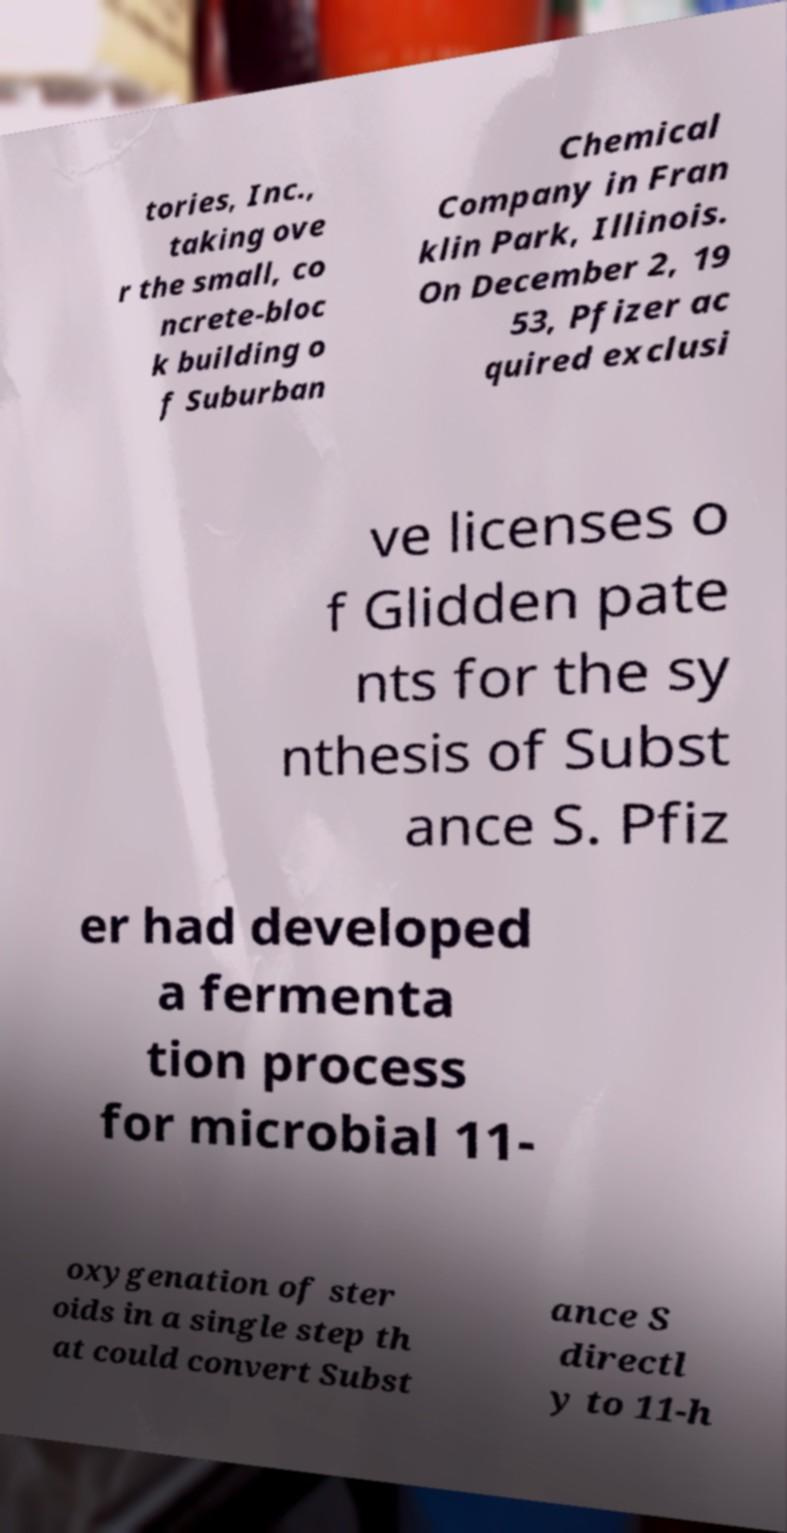Could you assist in decoding the text presented in this image and type it out clearly? tories, Inc., taking ove r the small, co ncrete-bloc k building o f Suburban Chemical Company in Fran klin Park, Illinois. On December 2, 19 53, Pfizer ac quired exclusi ve licenses o f Glidden pate nts for the sy nthesis of Subst ance S. Pfiz er had developed a fermenta tion process for microbial 11- oxygenation of ster oids in a single step th at could convert Subst ance S directl y to 11-h 